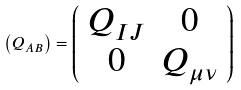<formula> <loc_0><loc_0><loc_500><loc_500>\left ( Q _ { A B } \right ) = \left ( \begin{array} { c c } Q _ { I J } & 0 \\ 0 & Q _ { \mu \nu } \end{array} \right )</formula> 